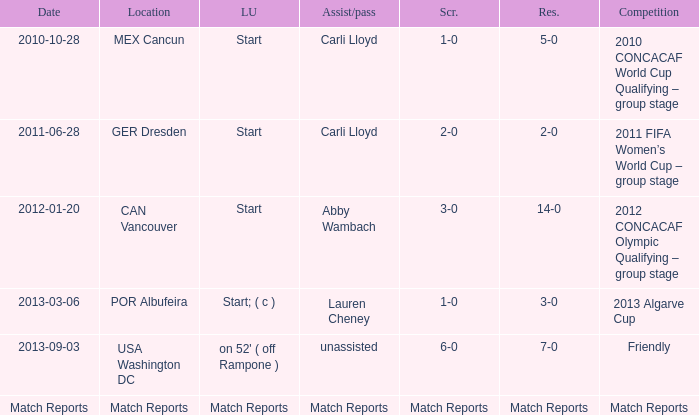I'm looking to parse the entire table for insights. Could you assist me with that? {'header': ['Date', 'Location', 'LU', 'Assist/pass', 'Scr.', 'Res.', 'Competition'], 'rows': [['2010-10-28', 'MEX Cancun', 'Start', 'Carli Lloyd', '1-0', '5-0', '2010 CONCACAF World Cup Qualifying – group stage'], ['2011-06-28', 'GER Dresden', 'Start', 'Carli Lloyd', '2-0', '2-0', '2011 FIFA Women’s World Cup – group stage'], ['2012-01-20', 'CAN Vancouver', 'Start', 'Abby Wambach', '3-0', '14-0', '2012 CONCACAF Olympic Qualifying – group stage'], ['2013-03-06', 'POR Albufeira', 'Start; ( c )', 'Lauren Cheney', '1-0', '3-0', '2013 Algarve Cup'], ['2013-09-03', 'USA Washington DC', "on 52' ( off Rampone )", 'unassisted', '6-0', '7-0', 'Friendly'], ['Match Reports', 'Match Reports', 'Match Reports', 'Match Reports', 'Match Reports', 'Match Reports', 'Match Reports']]} Where has a score of match reports? Match Reports. 